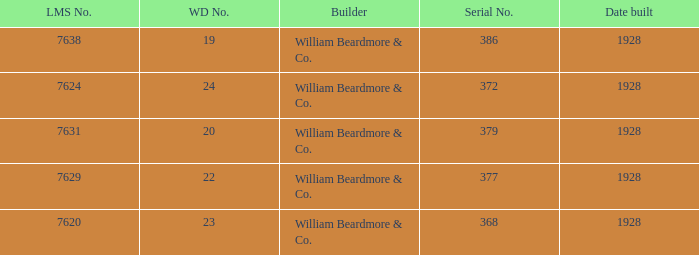Name the builder for serial number being 377 William Beardmore & Co. 